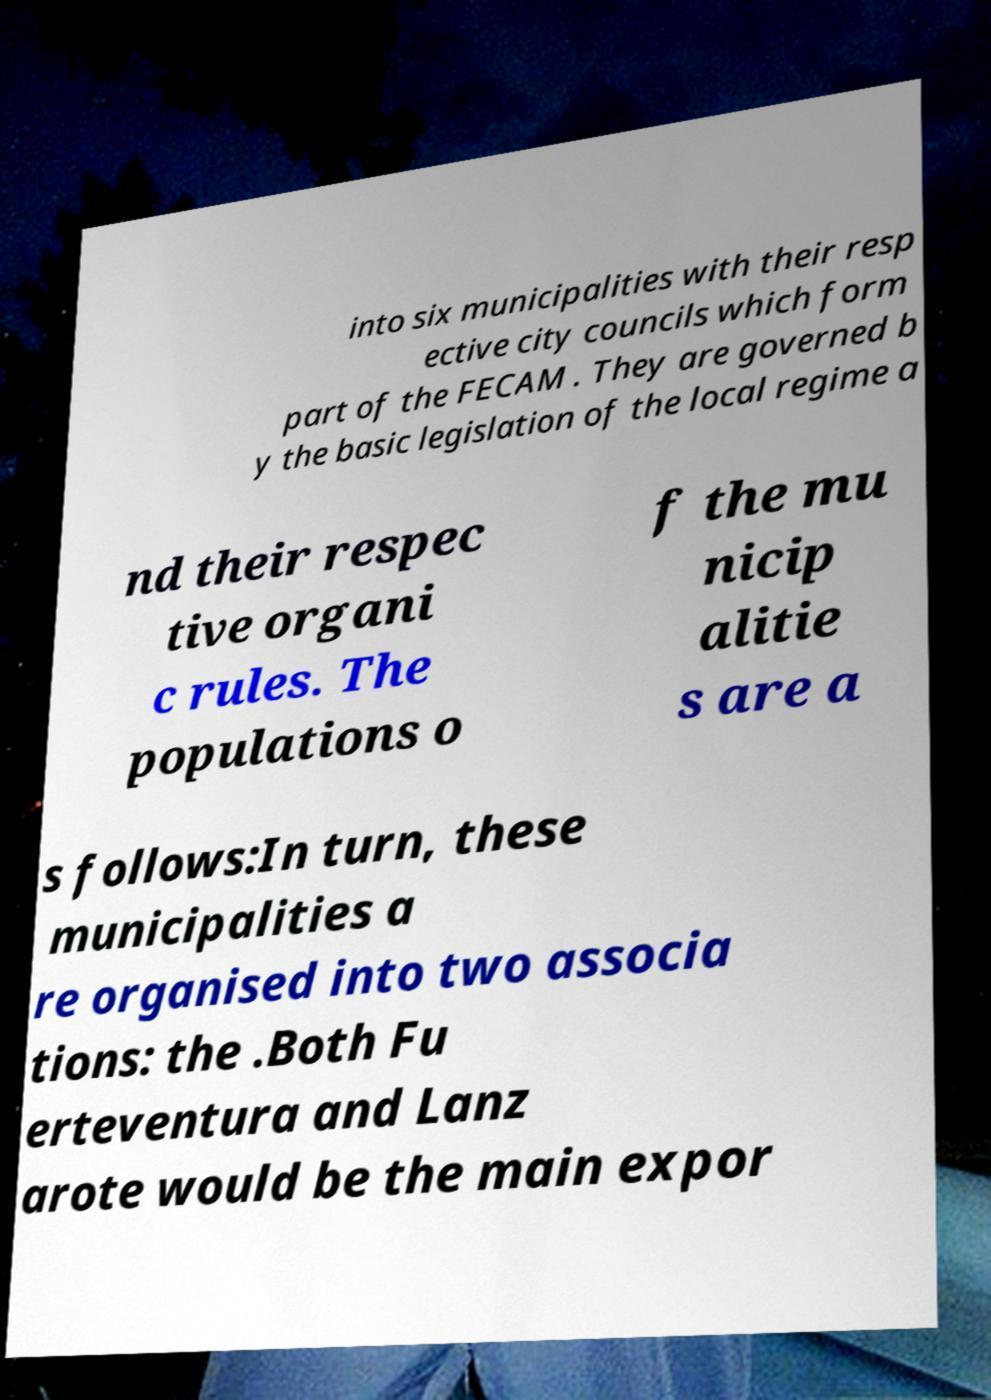Could you assist in decoding the text presented in this image and type it out clearly? into six municipalities with their resp ective city councils which form part of the FECAM . They are governed b y the basic legislation of the local regime a nd their respec tive organi c rules. The populations o f the mu nicip alitie s are a s follows:In turn, these municipalities a re organised into two associa tions: the .Both Fu erteventura and Lanz arote would be the main expor 